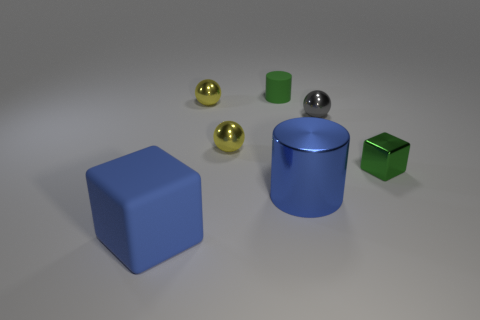Subtract all yellow spheres. How many spheres are left? 1 Add 2 yellow spheres. How many objects exist? 9 Subtract all blocks. How many objects are left? 5 Subtract 0 red cubes. How many objects are left? 7 Subtract all yellow metallic balls. Subtract all large shiny things. How many objects are left? 4 Add 3 tiny green cylinders. How many tiny green cylinders are left? 4 Add 2 purple shiny things. How many purple shiny things exist? 2 